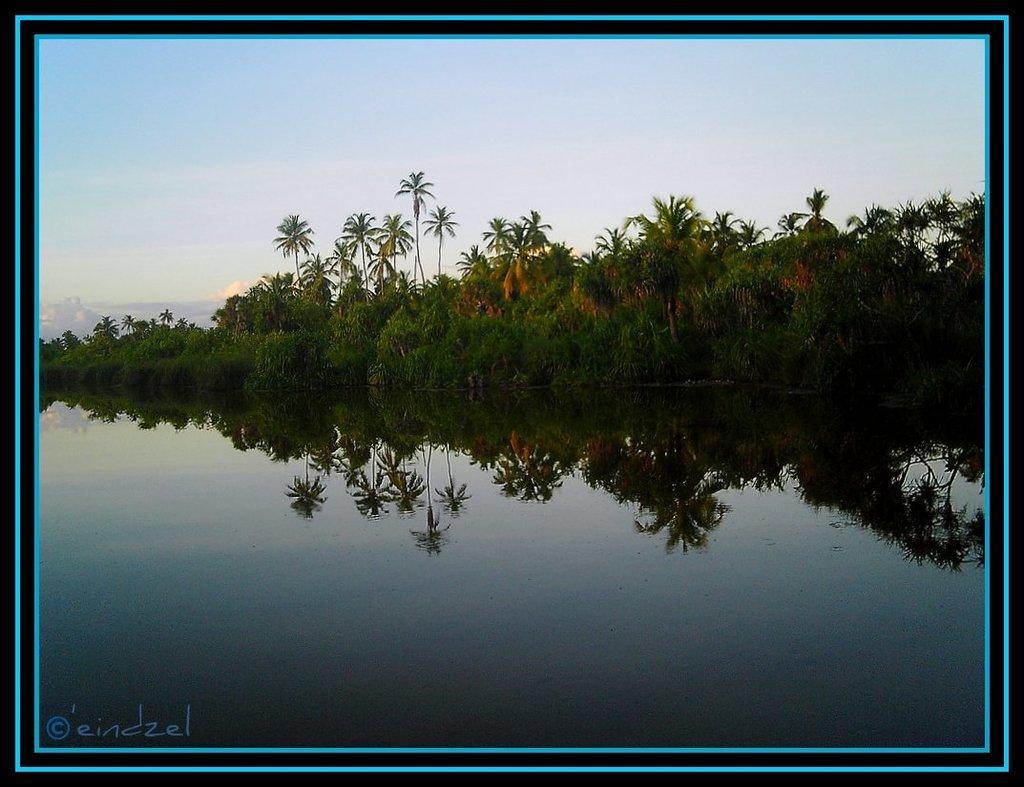Can you describe this image briefly? In this image we can see a water body, a group of trees and the sky which looks cloudy. 